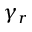<formula> <loc_0><loc_0><loc_500><loc_500>\gamma _ { r }</formula> 